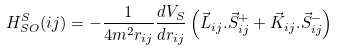<formula> <loc_0><loc_0><loc_500><loc_500>H ^ { S } _ { S O } ( i j ) = - \frac { 1 } { 4 m ^ { 2 } r _ { i j } } \frac { d V _ { S } } { d r _ { i j } } \left ( \vec { L } _ { i j } . \vec { S } _ { i j } ^ { + } + \vec { K } _ { i j } . \vec { S } _ { i j } ^ { - } \right )</formula> 